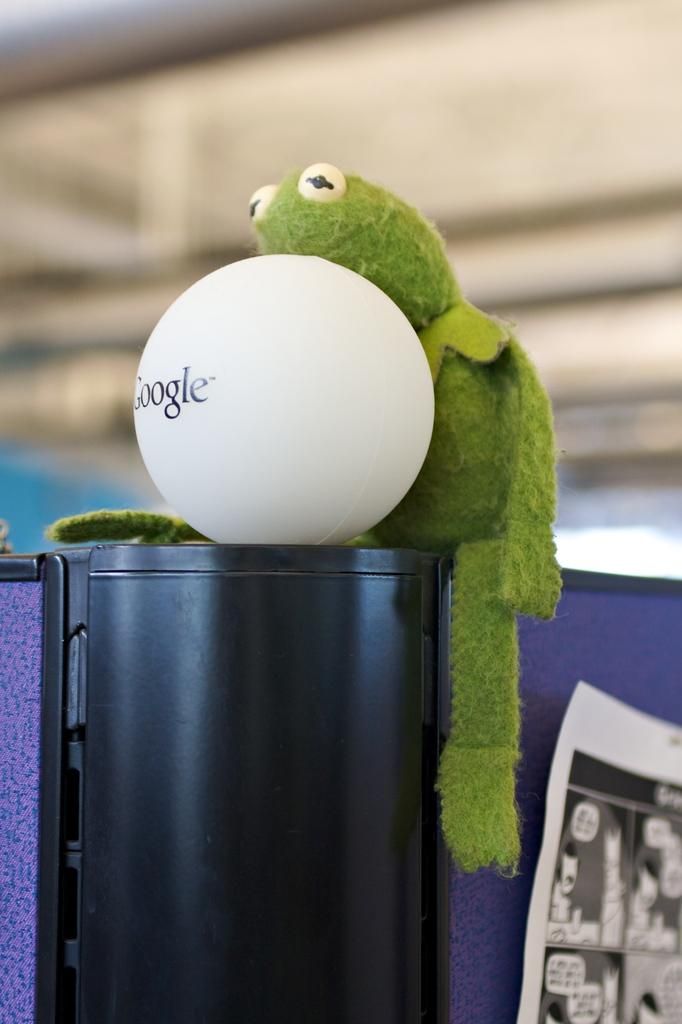What is the main object in the image? There is a white ball in the image. Where is the toy located in the image? The toy is placed on a black object in the image. What can be seen on the right side of the image? There is a poster on the right side of the image. How would you describe the background of the image? The background has a blurred view. What type of orange is being delivered in the parcel in the image? There is no orange or parcel present in the image. 